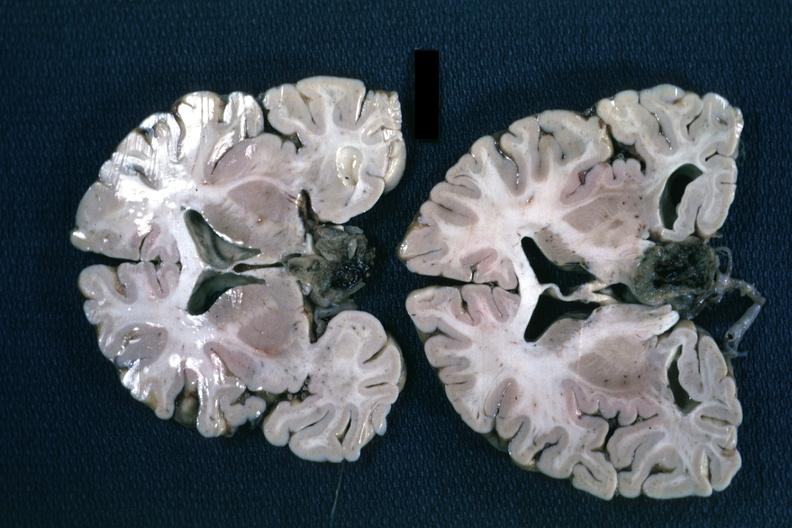what does this image show?
Answer the question using a single word or phrase. Fixed tissue coronal sections hemispheres with large inferior lesion 